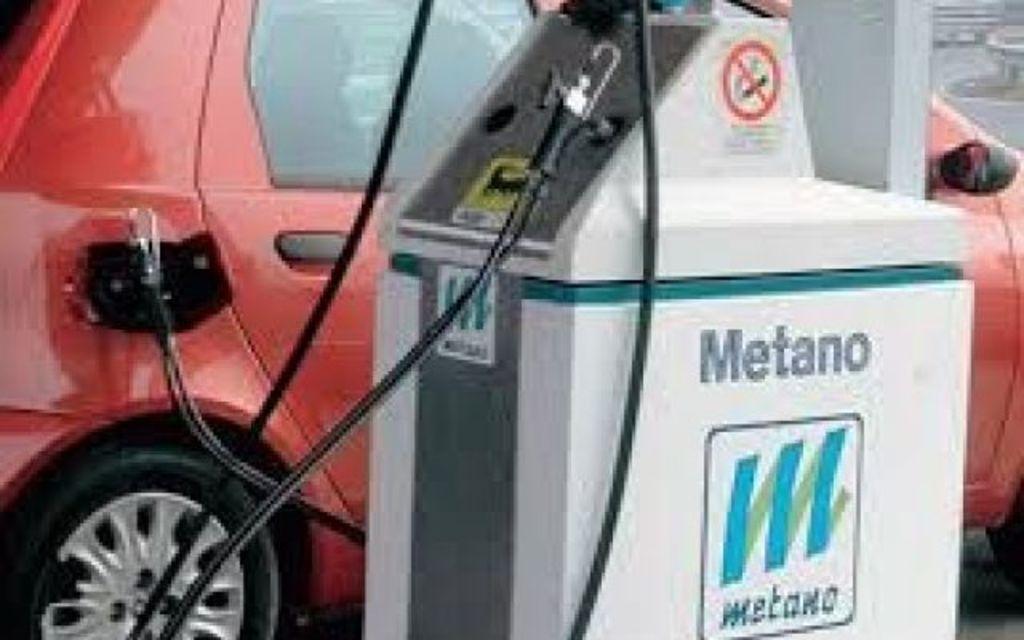How would you summarize this image in a sentence or two? In this image there is a petrol pumping machine and a red color car. 